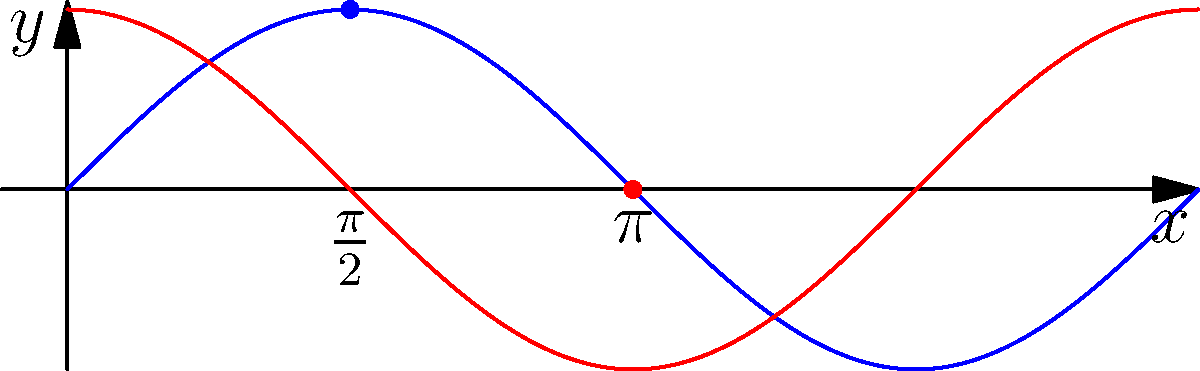In the context of ancient Greek contributions to trigonometry, which mathematician is credited with creating the first known table of chords, a precursor to modern sine tables, and how does this relate to the sinusoidal functions depicted in the graph? 1. The ancient Greek mathematician Hipparchus (190-120 BCE) is credited with creating the first known table of chords.

2. Hipparchus's table of chords was a significant step in the development of trigonometry, as it provided a systematic way to calculate the length of a chord given the central angle in a circle.

3. The chord function is closely related to the modern sine function. In fact, for a circle with radius $r$, the relationship between chord and sine is:

   $\text{chord}(θ) = 2r \sin(\frac{θ}{2})$

4. The blue curve in the graph represents the sine function, while the red curve represents the cosine function. These are the modern equivalents of the trigonometric ratios that evolved from ancient chord tables.

5. The sine function reaches its maximum value of 1 at $x = \frac{\pi}{2}$, which corresponds to a 90° angle in the unit circle. This point is marked with a blue dot on the graph.

6. The cosine function reaches zero at $x = \pi$, corresponding to a 180° angle. This point is marked with a red dot on the graph.

7. Hipparchus's work laid the foundation for later developments in trigonometry, including the transition from chord tables to sine tables by Indian mathematicians, and eventually to the modern trigonometric functions we use today.

8. The graph illustrates how these functions behave over a full rotation (0 to 2π), showcasing the periodicity and symmetry that make trigonometric functions so useful in mathematics and various scientific fields.
Answer: Hipparchus; created first known table of chords, precursor to sine tables 